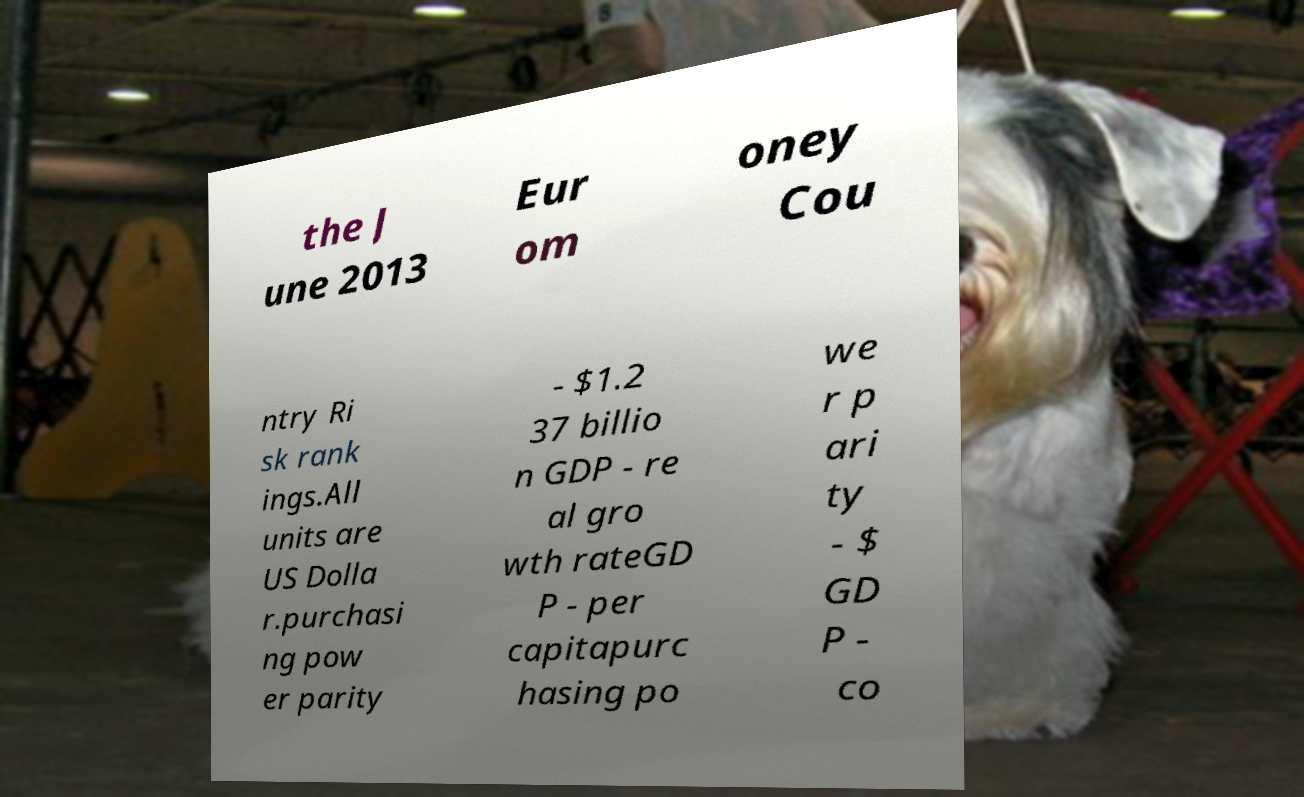What messages or text are displayed in this image? I need them in a readable, typed format. the J une 2013 Eur om oney Cou ntry Ri sk rank ings.All units are US Dolla r.purchasi ng pow er parity - $1.2 37 billio n GDP - re al gro wth rateGD P - per capitapurc hasing po we r p ari ty - $ GD P - co 